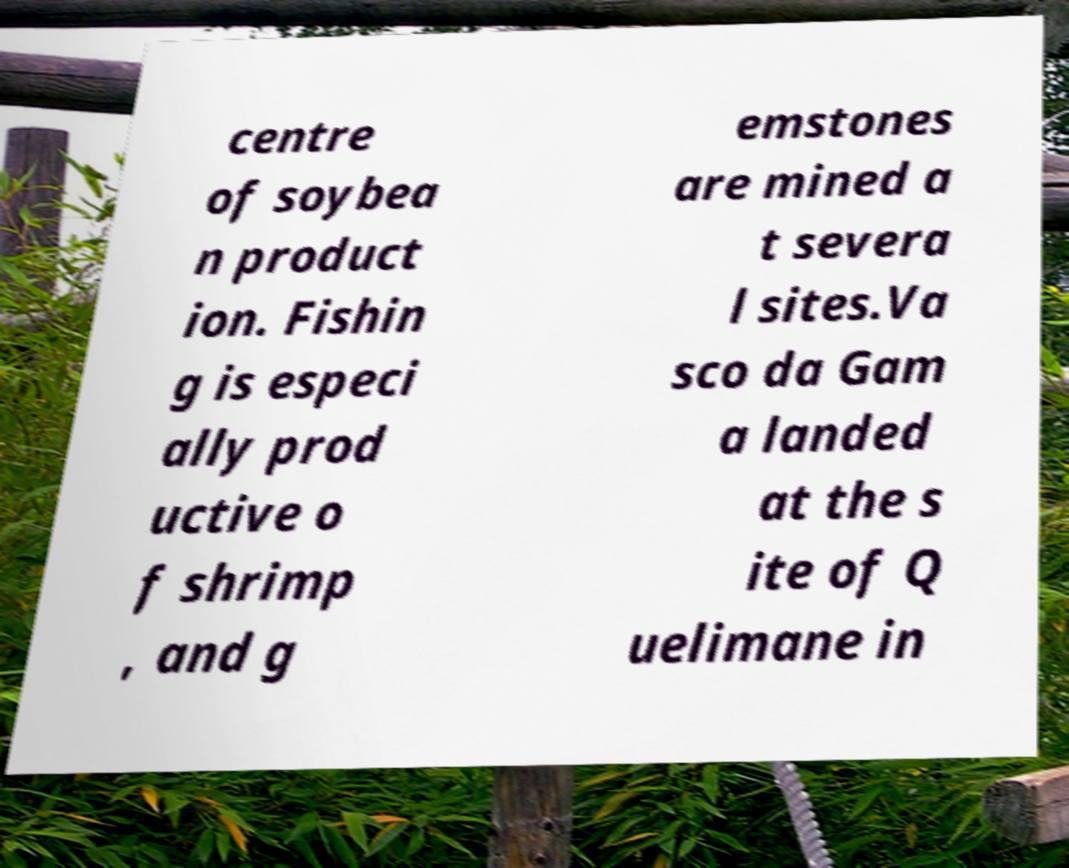Please identify and transcribe the text found in this image. centre of soybea n product ion. Fishin g is especi ally prod uctive o f shrimp , and g emstones are mined a t severa l sites.Va sco da Gam a landed at the s ite of Q uelimane in 